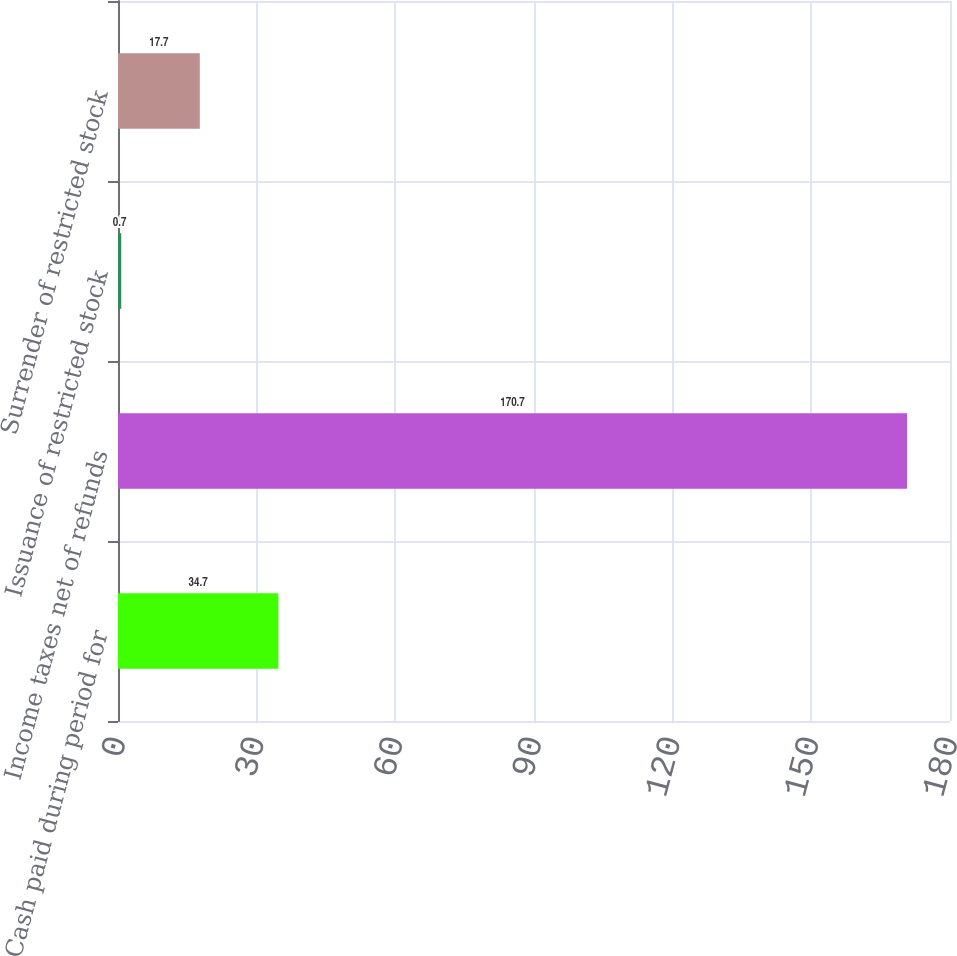Convert chart. <chart><loc_0><loc_0><loc_500><loc_500><bar_chart><fcel>Cash paid during period for<fcel>Income taxes net of refunds<fcel>Issuance of restricted stock<fcel>Surrender of restricted stock<nl><fcel>34.7<fcel>170.7<fcel>0.7<fcel>17.7<nl></chart> 